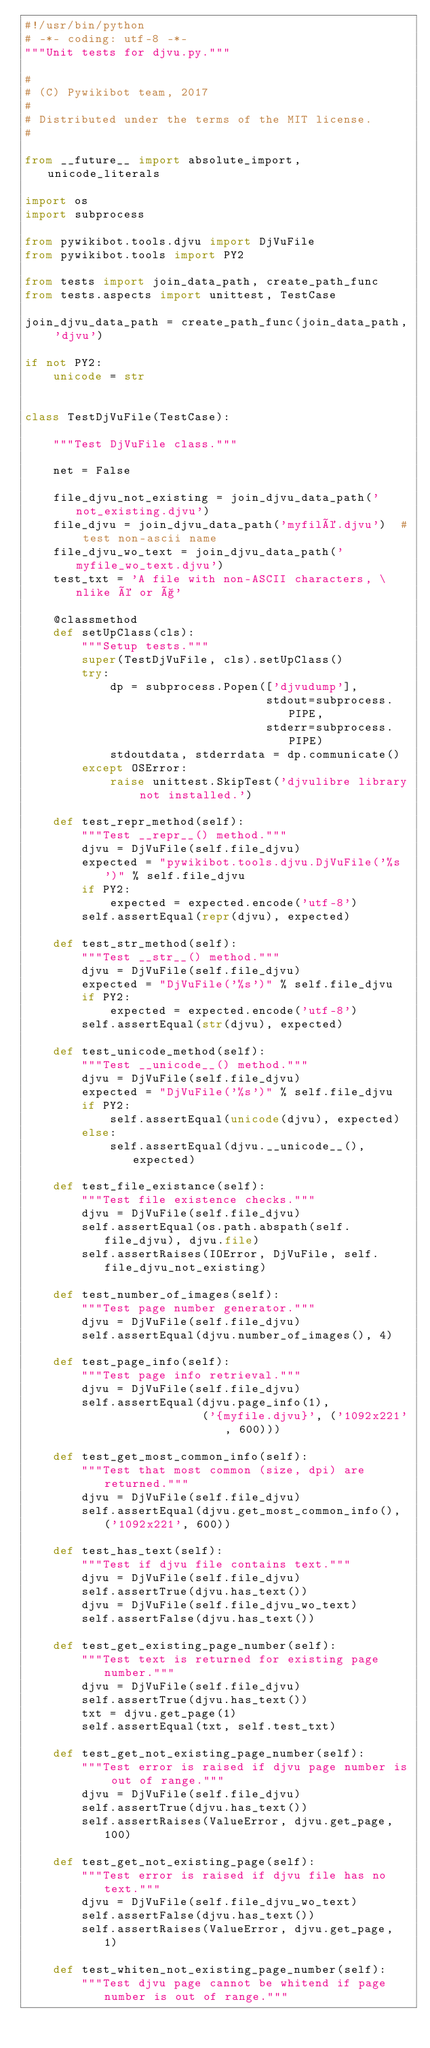Convert code to text. <code><loc_0><loc_0><loc_500><loc_500><_Python_>#!/usr/bin/python
# -*- coding: utf-8 -*-
"""Unit tests for djvu.py."""

#
# (C) Pywikibot team, 2017
#
# Distributed under the terms of the MIT license.
#

from __future__ import absolute_import, unicode_literals

import os
import subprocess

from pywikibot.tools.djvu import DjVuFile
from pywikibot.tools import PY2

from tests import join_data_path, create_path_func
from tests.aspects import unittest, TestCase

join_djvu_data_path = create_path_func(join_data_path, 'djvu')

if not PY2:
    unicode = str


class TestDjVuFile(TestCase):

    """Test DjVuFile class."""

    net = False

    file_djvu_not_existing = join_djvu_data_path('not_existing.djvu')
    file_djvu = join_djvu_data_path('myfilé.djvu')  # test non-ascii name
    file_djvu_wo_text = join_djvu_data_path('myfile_wo_text.djvu')
    test_txt = 'A file with non-ASCII characters, \nlike é or ç'

    @classmethod
    def setUpClass(cls):
        """Setup tests."""
        super(TestDjVuFile, cls).setUpClass()
        try:
            dp = subprocess.Popen(['djvudump'],
                                  stdout=subprocess.PIPE,
                                  stderr=subprocess.PIPE)
            stdoutdata, stderrdata = dp.communicate()
        except OSError:
            raise unittest.SkipTest('djvulibre library not installed.')

    def test_repr_method(self):
        """Test __repr__() method."""
        djvu = DjVuFile(self.file_djvu)
        expected = "pywikibot.tools.djvu.DjVuFile('%s')" % self.file_djvu
        if PY2:
            expected = expected.encode('utf-8')
        self.assertEqual(repr(djvu), expected)

    def test_str_method(self):
        """Test __str__() method."""
        djvu = DjVuFile(self.file_djvu)
        expected = "DjVuFile('%s')" % self.file_djvu
        if PY2:
            expected = expected.encode('utf-8')
        self.assertEqual(str(djvu), expected)

    def test_unicode_method(self):
        """Test __unicode__() method."""
        djvu = DjVuFile(self.file_djvu)
        expected = "DjVuFile('%s')" % self.file_djvu
        if PY2:
            self.assertEqual(unicode(djvu), expected)
        else:
            self.assertEqual(djvu.__unicode__(), expected)

    def test_file_existance(self):
        """Test file existence checks."""
        djvu = DjVuFile(self.file_djvu)
        self.assertEqual(os.path.abspath(self.file_djvu), djvu.file)
        self.assertRaises(IOError, DjVuFile, self.file_djvu_not_existing)

    def test_number_of_images(self):
        """Test page number generator."""
        djvu = DjVuFile(self.file_djvu)
        self.assertEqual(djvu.number_of_images(), 4)

    def test_page_info(self):
        """Test page info retrieval."""
        djvu = DjVuFile(self.file_djvu)
        self.assertEqual(djvu.page_info(1),
                         ('{myfile.djvu}', ('1092x221', 600)))

    def test_get_most_common_info(self):
        """Test that most common (size, dpi) are returned."""
        djvu = DjVuFile(self.file_djvu)
        self.assertEqual(djvu.get_most_common_info(), ('1092x221', 600))

    def test_has_text(self):
        """Test if djvu file contains text."""
        djvu = DjVuFile(self.file_djvu)
        self.assertTrue(djvu.has_text())
        djvu = DjVuFile(self.file_djvu_wo_text)
        self.assertFalse(djvu.has_text())

    def test_get_existing_page_number(self):
        """Test text is returned for existing page number."""
        djvu = DjVuFile(self.file_djvu)
        self.assertTrue(djvu.has_text())
        txt = djvu.get_page(1)
        self.assertEqual(txt, self.test_txt)

    def test_get_not_existing_page_number(self):
        """Test error is raised if djvu page number is out of range."""
        djvu = DjVuFile(self.file_djvu)
        self.assertTrue(djvu.has_text())
        self.assertRaises(ValueError, djvu.get_page, 100)

    def test_get_not_existing_page(self):
        """Test error is raised if djvu file has no text."""
        djvu = DjVuFile(self.file_djvu_wo_text)
        self.assertFalse(djvu.has_text())
        self.assertRaises(ValueError, djvu.get_page, 1)

    def test_whiten_not_existing_page_number(self):
        """Test djvu page cannot be whitend if page number is out of range."""</code> 